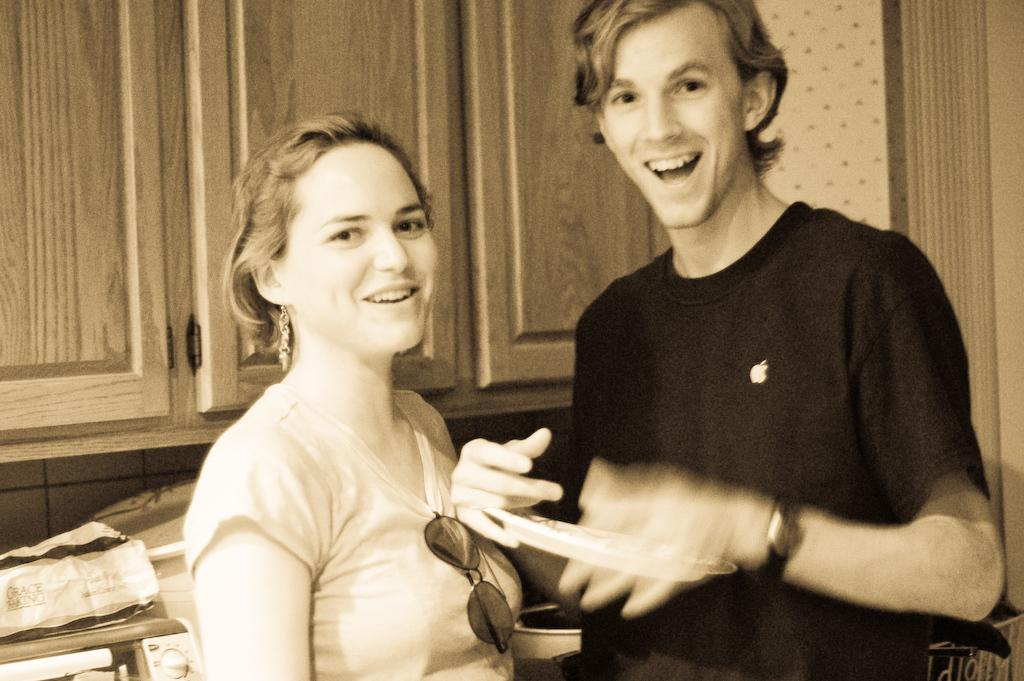How many people are in the image? There are persons standing in the image. What is the facial expression of the persons in the image? The persons are smiling. What can be seen in the background of the image? There is a wardrobe in the background of the image. What is located under the wardrobe? There are objects under the wardrobe. What type of books can be seen on the mouths of the persons in the image? There are no books or mouths mentioned in the image; it only states that the persons are smiling. 